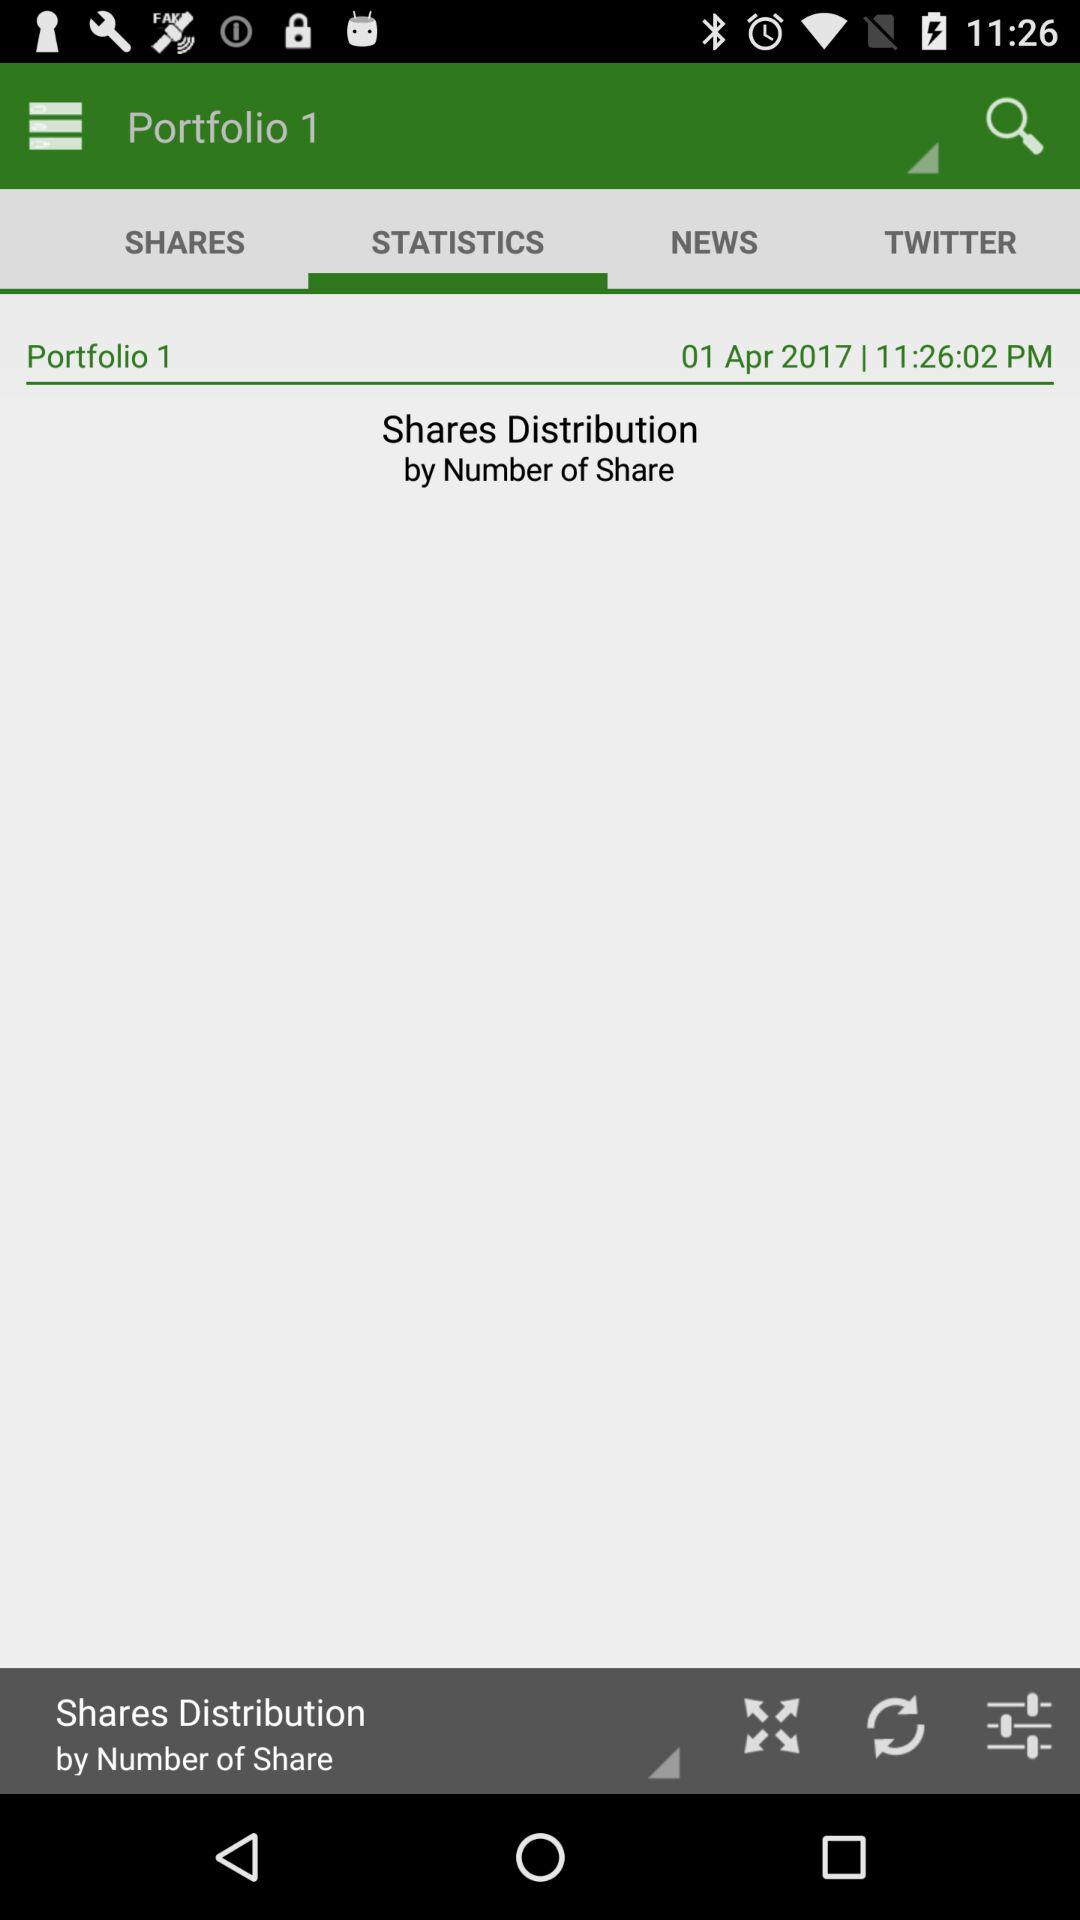What is the given time? The given time is 11:26:02 PM. 